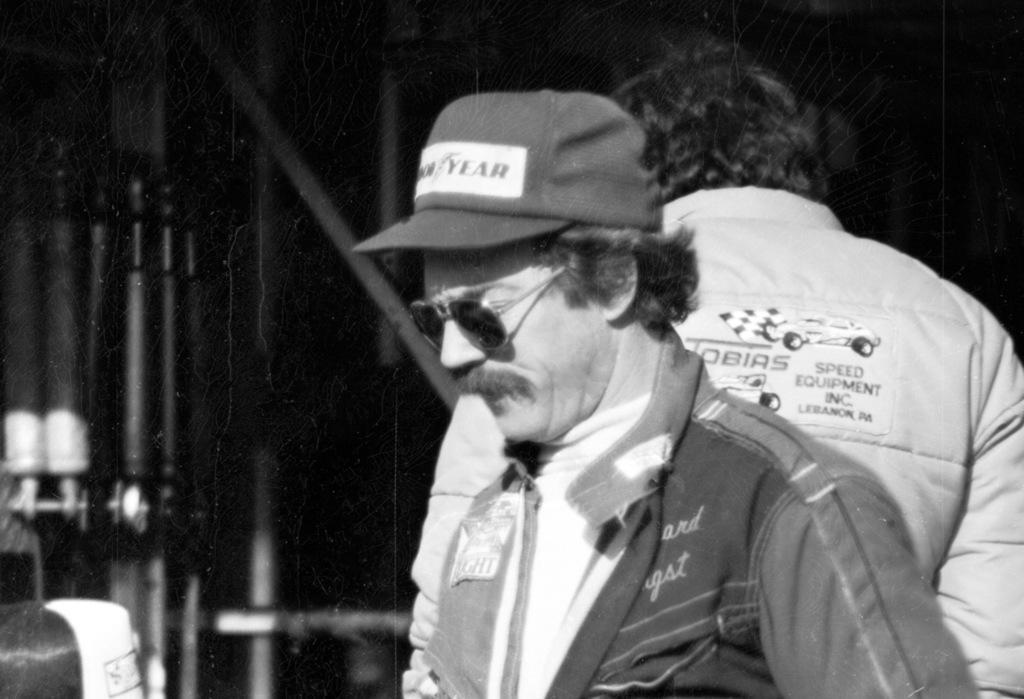Please provide a concise description of this image. This is a black and white image. In this image we can see men standing and grills in the background. 